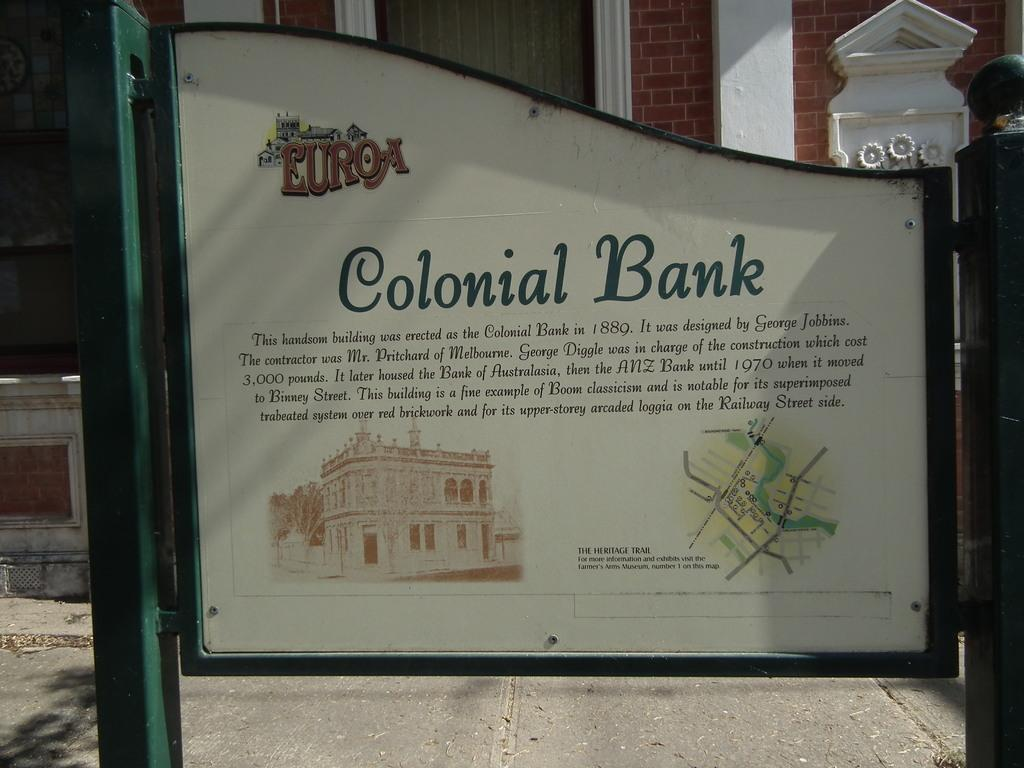<image>
Provide a brief description of the given image. A sign talking about the historic Colonial Bank building which was built in 1889 